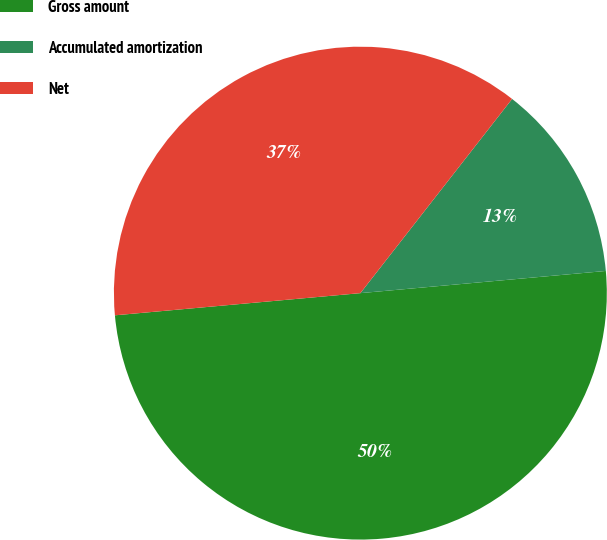<chart> <loc_0><loc_0><loc_500><loc_500><pie_chart><fcel>Gross amount<fcel>Accumulated amortization<fcel>Net<nl><fcel>50.0%<fcel>13.01%<fcel>36.99%<nl></chart> 